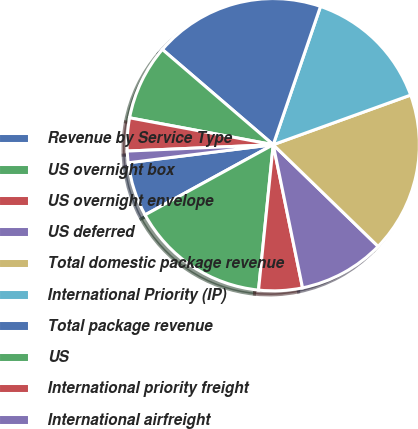Convert chart to OTSL. <chart><loc_0><loc_0><loc_500><loc_500><pie_chart><fcel>Revenue by Service Type<fcel>US overnight box<fcel>US overnight envelope<fcel>US deferred<fcel>Total domestic package revenue<fcel>International Priority (IP)<fcel>Total package revenue<fcel>US<fcel>International priority freight<fcel>International airfreight<nl><fcel>6.0%<fcel>15.42%<fcel>4.82%<fcel>9.53%<fcel>17.77%<fcel>14.24%<fcel>18.95%<fcel>8.35%<fcel>3.64%<fcel>1.28%<nl></chart> 